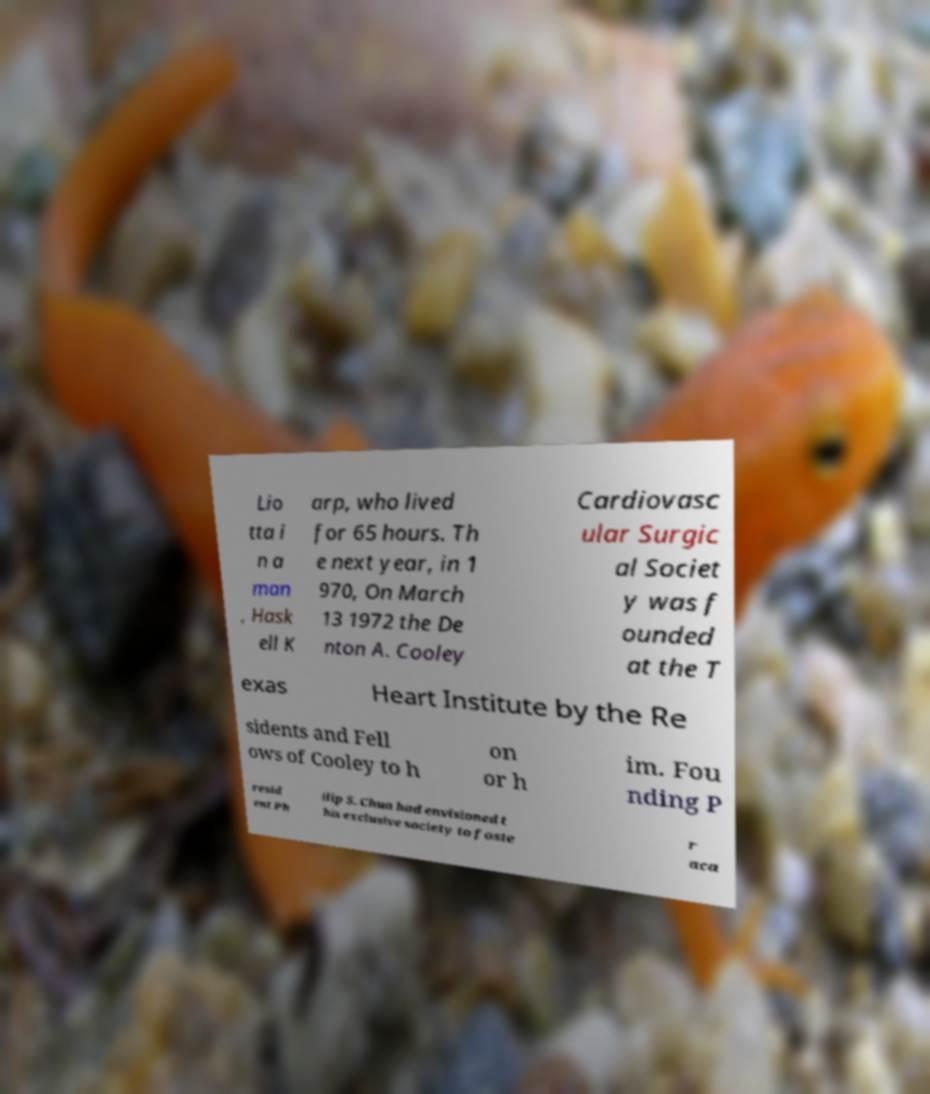Please read and relay the text visible in this image. What does it say? Lio tta i n a man , Hask ell K arp, who lived for 65 hours. Th e next year, in 1 970, On March 13 1972 the De nton A. Cooley Cardiovasc ular Surgic al Societ y was f ounded at the T exas Heart Institute by the Re sidents and Fell ows of Cooley to h on or h im. Fou nding P resid ent Ph ilip S. Chua had envisioned t his exclusive society to foste r aca 